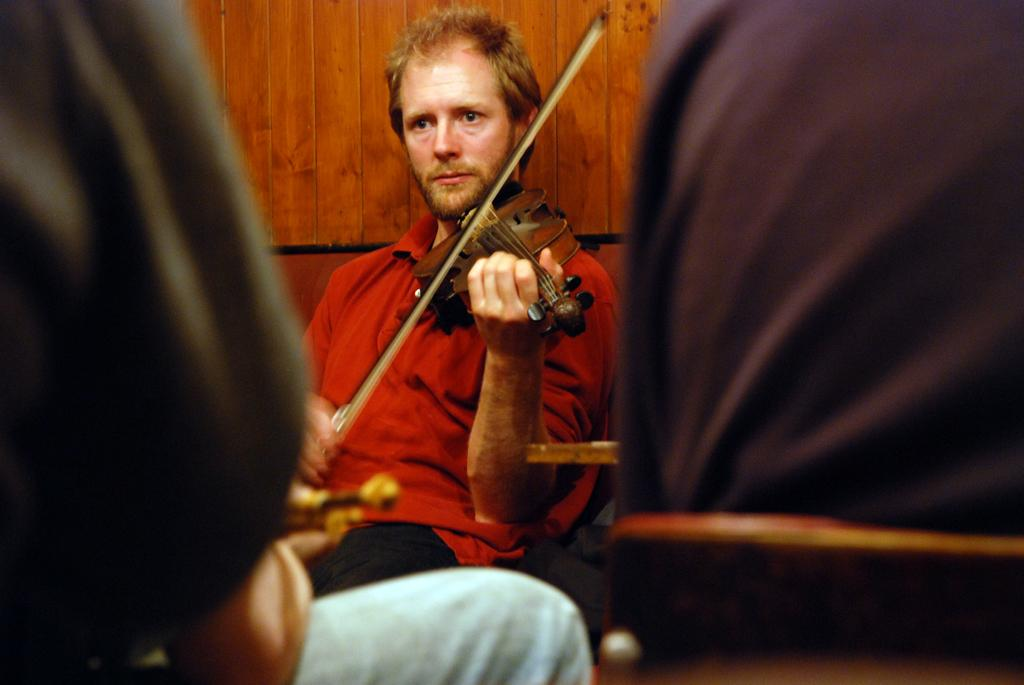What is the main subject of the image? There is a person in the image. What is the person doing in the image? The person is playing a musical instrument. What type of crate is the person using to play the musical instrument in the image? There is no crate present in the image; the person is playing a musical instrument without any visible crates. Can you describe the bear that is accompanying the person in the image? There is no bear present in the image; the person is alone while playing the musical instrument. 